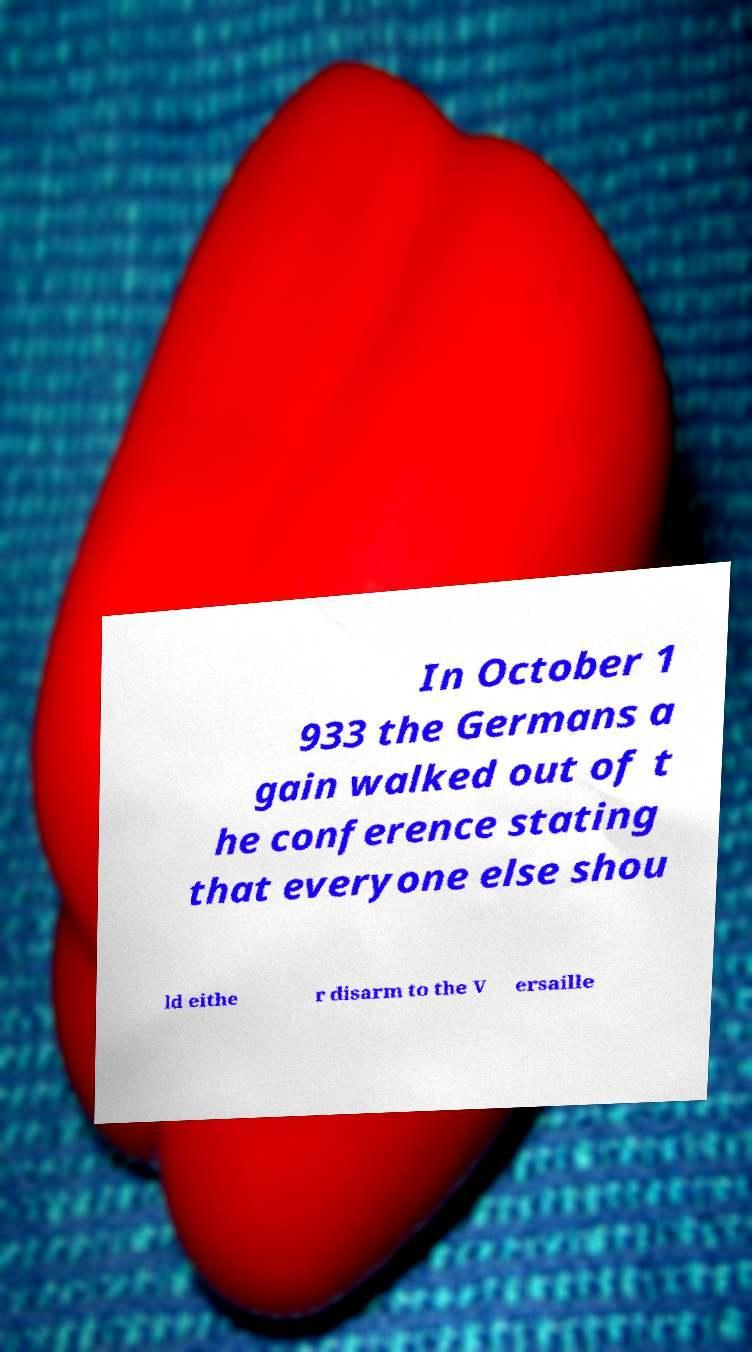There's text embedded in this image that I need extracted. Can you transcribe it verbatim? In October 1 933 the Germans a gain walked out of t he conference stating that everyone else shou ld eithe r disarm to the V ersaille 